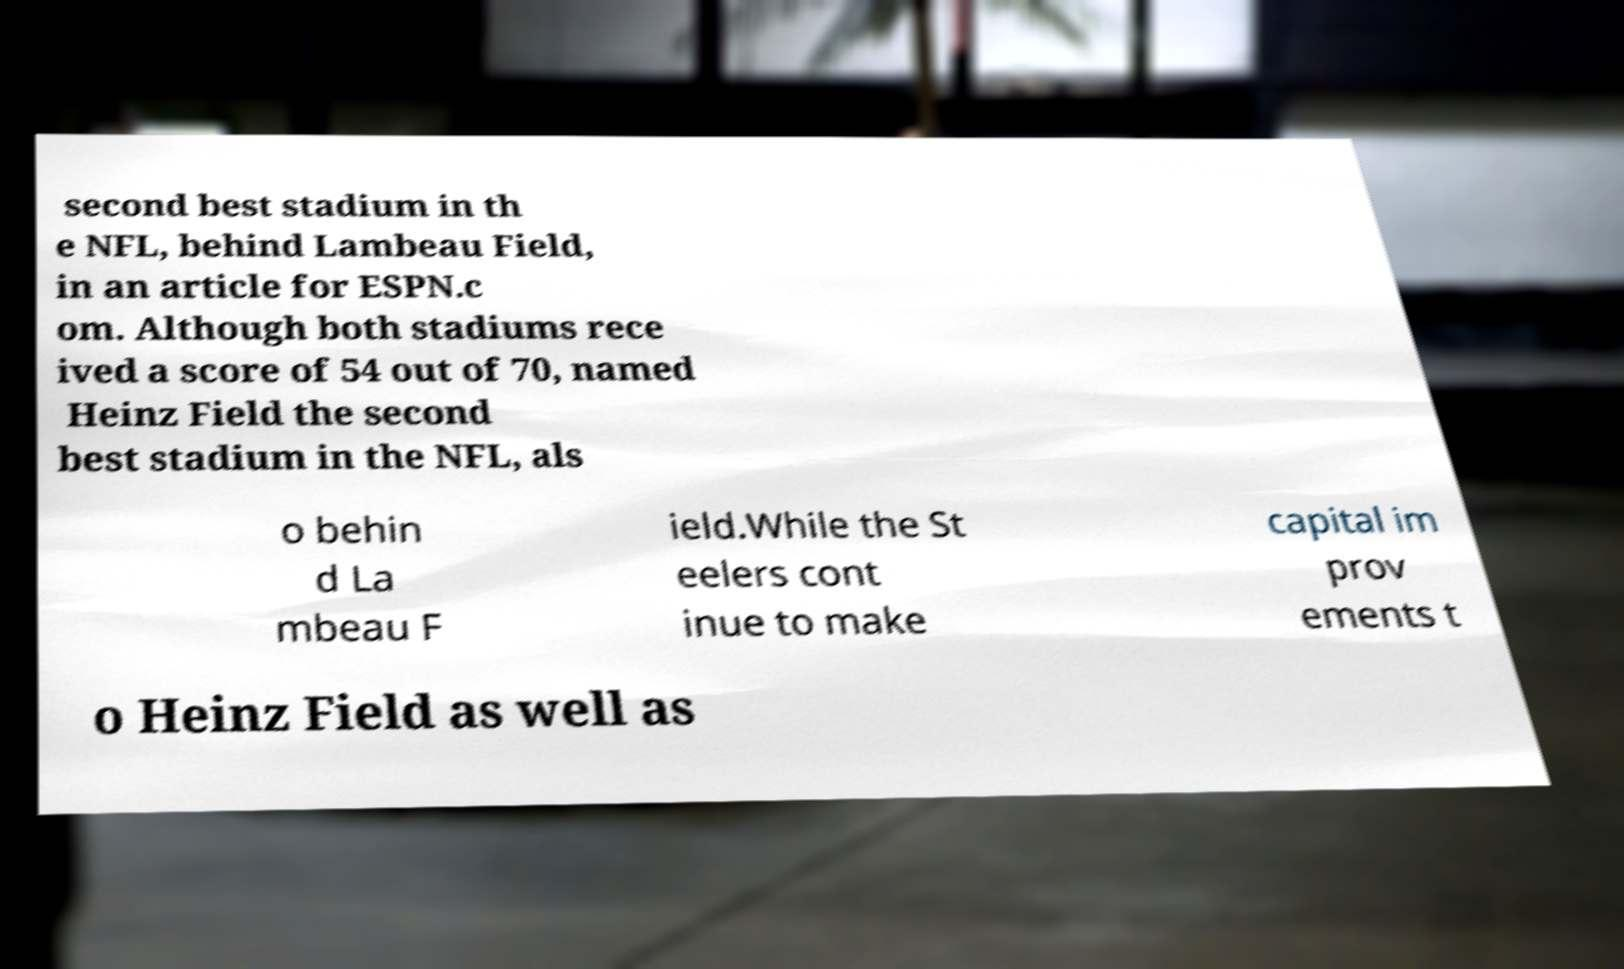I need the written content from this picture converted into text. Can you do that? second best stadium in th e NFL, behind Lambeau Field, in an article for ESPN.c om. Although both stadiums rece ived a score of 54 out of 70, named Heinz Field the second best stadium in the NFL, als o behin d La mbeau F ield.While the St eelers cont inue to make capital im prov ements t o Heinz Field as well as 